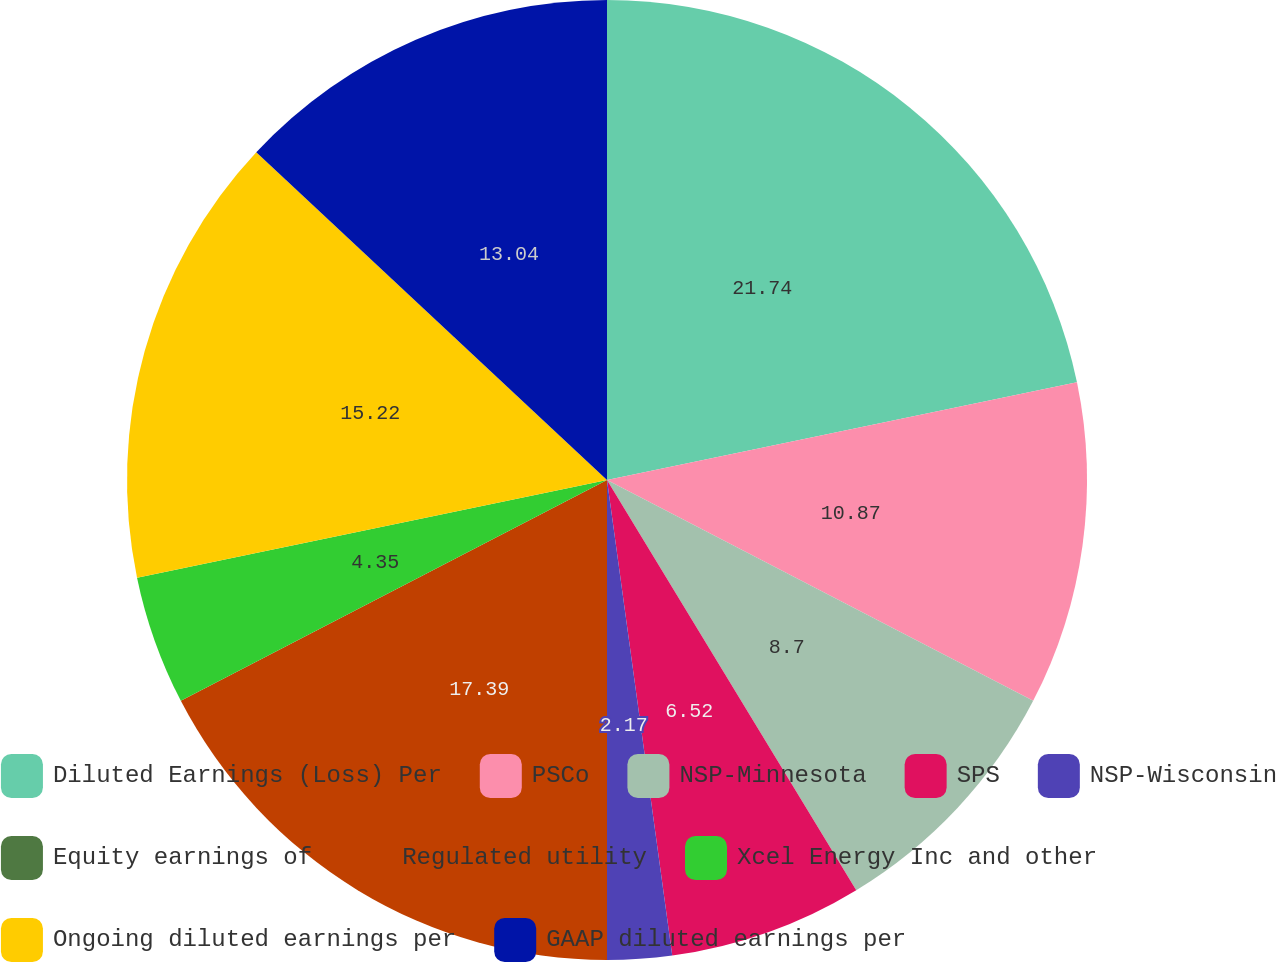Convert chart. <chart><loc_0><loc_0><loc_500><loc_500><pie_chart><fcel>Diluted Earnings (Loss) Per<fcel>PSCo<fcel>NSP-Minnesota<fcel>SPS<fcel>NSP-Wisconsin<fcel>Equity earnings of<fcel>Regulated utility<fcel>Xcel Energy Inc and other<fcel>Ongoing diluted earnings per<fcel>GAAP diluted earnings per<nl><fcel>21.74%<fcel>10.87%<fcel>8.7%<fcel>6.52%<fcel>2.17%<fcel>0.0%<fcel>17.39%<fcel>4.35%<fcel>15.22%<fcel>13.04%<nl></chart> 